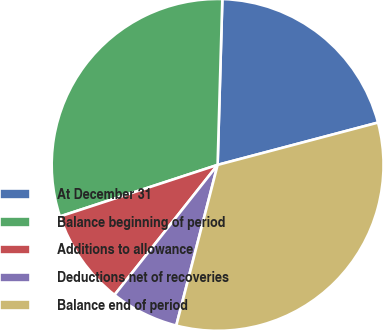<chart> <loc_0><loc_0><loc_500><loc_500><pie_chart><fcel>At December 31<fcel>Balance beginning of period<fcel>Additions to allowance<fcel>Deductions net of recoveries<fcel>Balance end of period<nl><fcel>20.44%<fcel>30.48%<fcel>9.3%<fcel>6.66%<fcel>33.11%<nl></chart> 